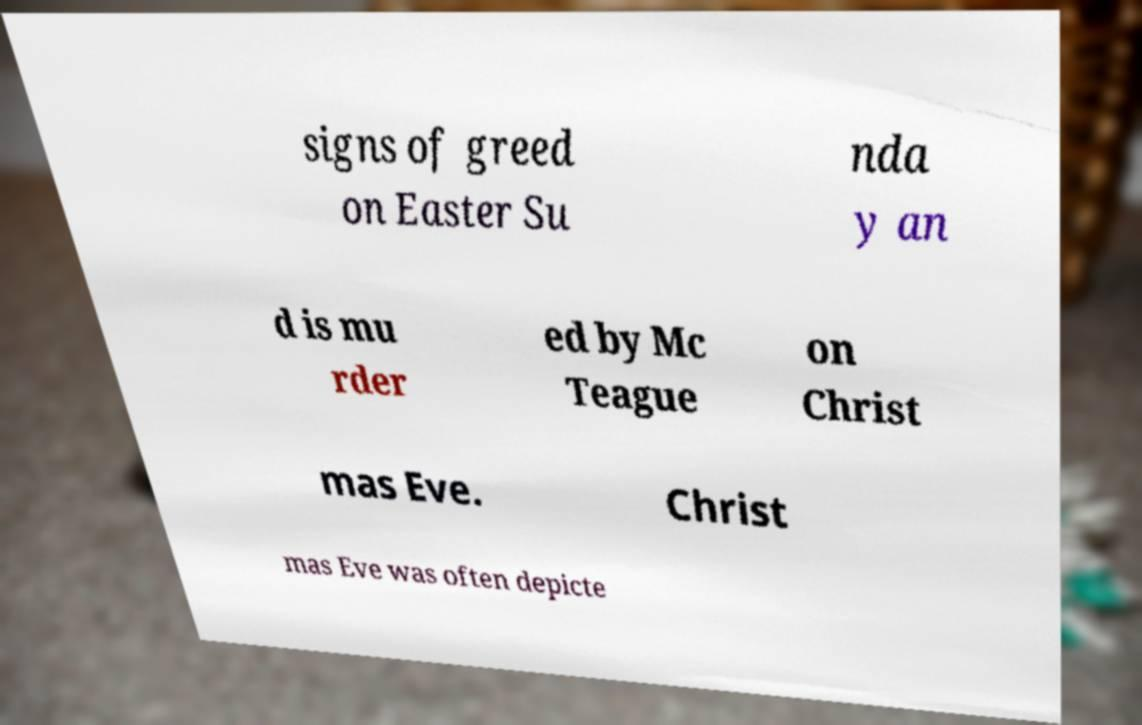Can you read and provide the text displayed in the image?This photo seems to have some interesting text. Can you extract and type it out for me? signs of greed on Easter Su nda y an d is mu rder ed by Mc Teague on Christ mas Eve. Christ mas Eve was often depicte 